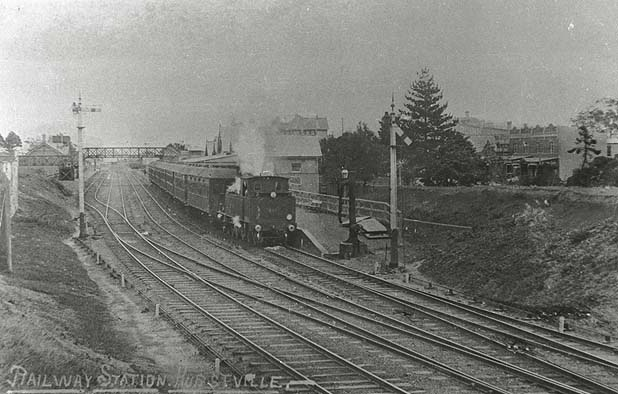Describe the objects in this image and their specific colors. I can see train in white, gray, black, and darkgray tones and traffic light in white, darkgray, lightgray, and gray tones in this image. 